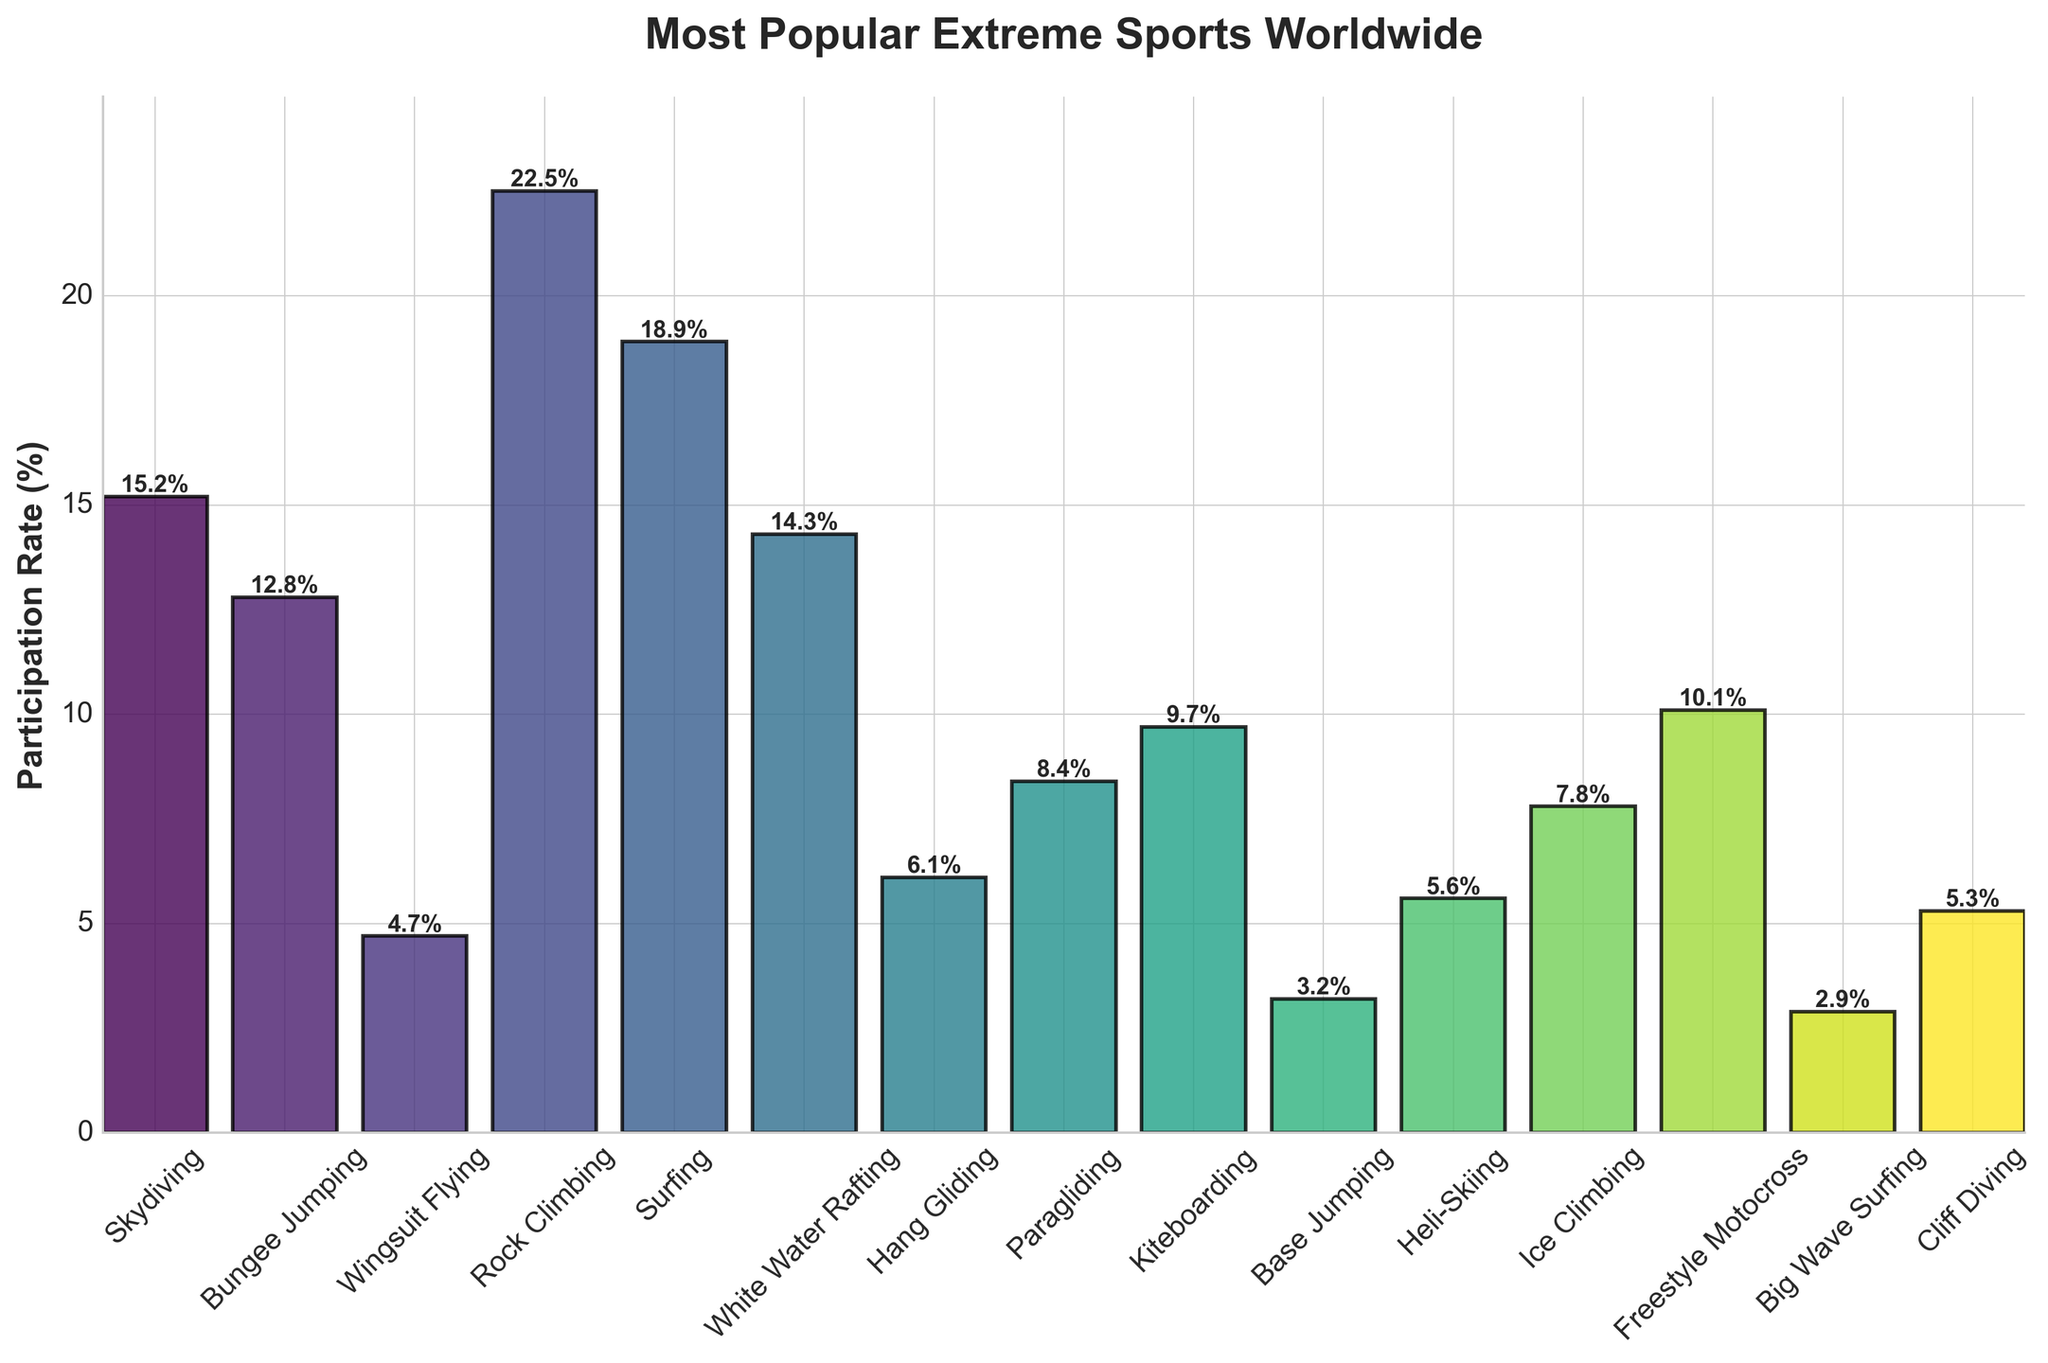Which extreme sport has the highest participation rate? Look at the height of the bars, the tallest bar represents the sport with the highest participation rate. The tallest bar corresponds to Rock Climbing.
Answer: Rock Climbing What is the difference in participation rates between Skydiving and Bungee Jumping? Find the heights of the bars for Skydiving and Bungee Jumping, which are 15.2% and 12.8% respectively. Then subtract the smaller value from the larger one: 15.2% - 12.8% = 2.4%.
Answer: 2.4% How many sports have participation rates higher than 10%? Count the number of bars that reach above the 10% mark. The qualifying sports are Skydiving, Bungee Jumping, Rock Climbing, Surfing, White Water Rafting, Kiteboarding, and Freestyle Motocross. This amounts to 7 sports.
Answer: 7 What is the combined participation rate of the least popular three sports? Identify the three sports with the shortest bars, which are Big Wave Surfing (2.9%), Base Jumping (3.2%), and Wingsuit Flying (4.7%). Add these rates together: 2.9% + 3.2% + 4.7% = 10.8%.
Answer: 10.8% Which sport has a higher participation rate: Ice Climbing or Hang Gliding? Compare the heights of the bars for Ice Climbing and Hang Gliding. Ice Climbing has a rate of 7.8%, and Hang Gliding has a rate of 6.1%.
Answer: Ice Climbing What’s the participation rate difference between the most and least popular extreme sports? Identify the highest and lowest bars. Rock Climbing (22.5%) is the highest, and Big Wave Surfing (2.9%) is the lowest. The difference is 22.5% - 2.9% = 19.6%.
Answer: 19.6% Which sport has a participation rate closest to 10%? Look at the bars and find the one closest to the 10% mark. Freestyle Motocross has a participation rate of 10.1%, which is the closest.
Answer: Freestyle Motocross How does the participation rate of Surfing compare to that of Paragliding? Look at the height of the bars for Surfing and Paragliding. Surfing has a rate of 18.9%, and Paragliding has a rate of 8.4%. Surfing's bar is higher.
Answer: Surfing has a higher rate Which sport has the fourth highest participation rate? Rank the sports by the height of their bars. The first three highest are Rock Climbing, Surfing, and Skydiving. The fourth highest is Bungee Jumping with 12.8%.
Answer: Bungee Jumping 